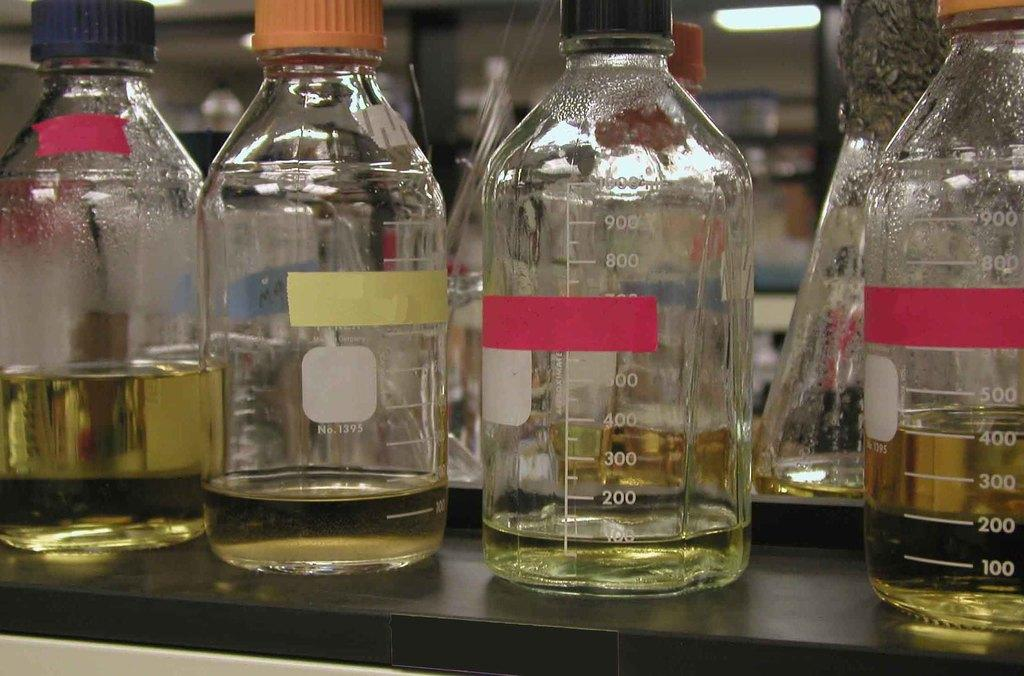Provide a one-sentence caption for the provided image. Jars with a yellowish liquid in them with the most filled done having 400 ml in it. 